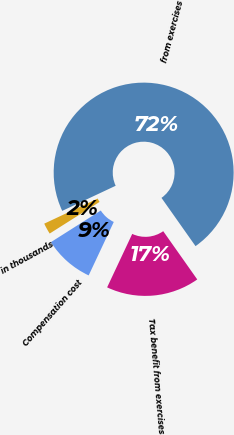Convert chart to OTSL. <chart><loc_0><loc_0><loc_500><loc_500><pie_chart><fcel>in thousands<fcel>from exercises<fcel>Tax benefit from exercises<fcel>Compensation cost<nl><fcel>2.0%<fcel>72.22%<fcel>16.77%<fcel>9.02%<nl></chart> 